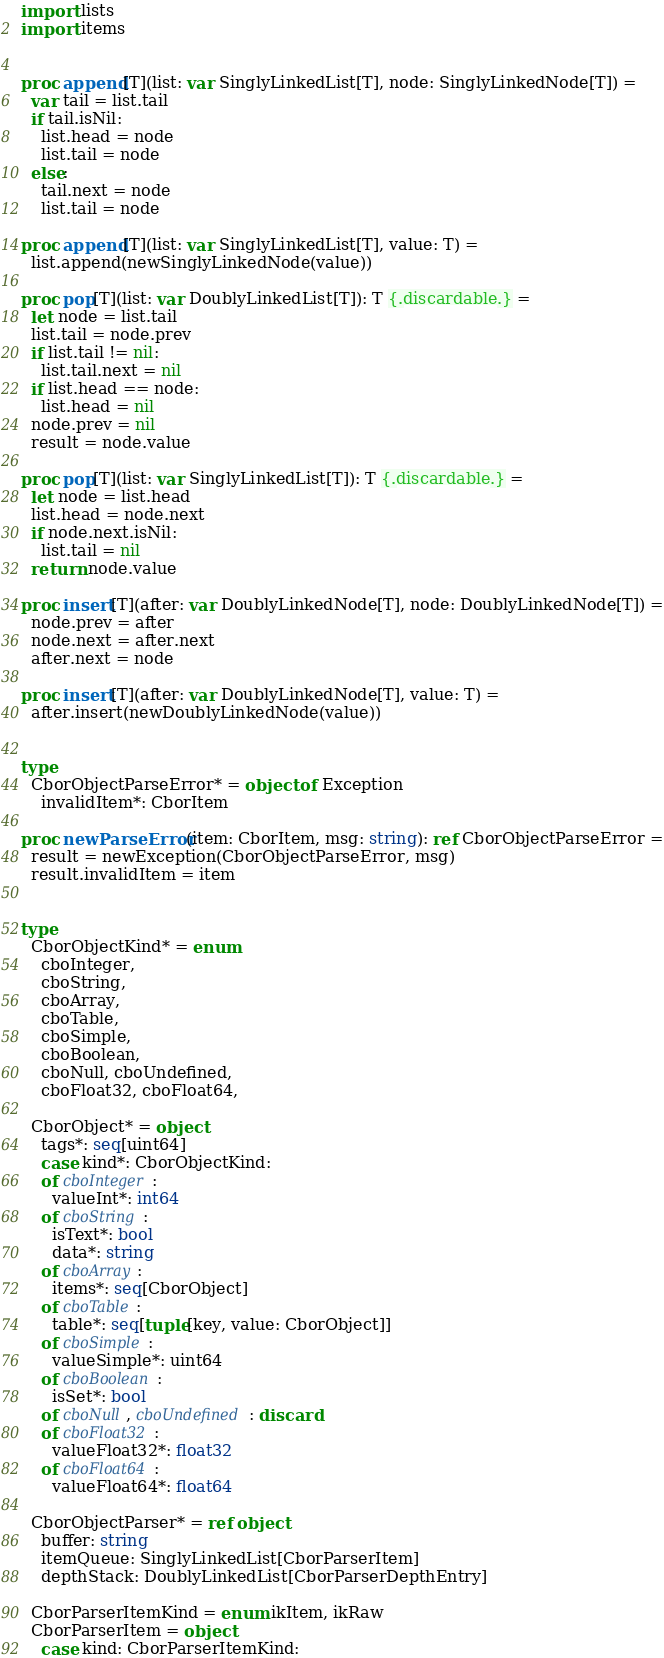<code> <loc_0><loc_0><loc_500><loc_500><_Nim_>import lists
import items


proc append[T](list: var SinglyLinkedList[T], node: SinglyLinkedNode[T]) =
  var tail = list.tail
  if tail.isNil:
    list.head = node
    list.tail = node
  else:
    tail.next = node
    list.tail = node

proc append[T](list: var SinglyLinkedList[T], value: T) =
  list.append(newSinglyLinkedNode(value))

proc pop[T](list: var DoublyLinkedList[T]): T {.discardable.} =
  let node = list.tail
  list.tail = node.prev
  if list.tail != nil:
    list.tail.next = nil
  if list.head == node:
    list.head = nil
  node.prev = nil
  result = node.value

proc pop[T](list: var SinglyLinkedList[T]): T {.discardable.} =
  let node = list.head
  list.head = node.next
  if node.next.isNil:
    list.tail = nil
  return node.value

proc insert[T](after: var DoublyLinkedNode[T], node: DoublyLinkedNode[T]) =
  node.prev = after
  node.next = after.next
  after.next = node

proc insert[T](after: var DoublyLinkedNode[T], value: T) =
  after.insert(newDoublyLinkedNode(value))


type
  CborObjectParseError* = object of Exception
    invalidItem*: CborItem

proc newParseError(item: CborItem, msg: string): ref CborObjectParseError =
  result = newException(CborObjectParseError, msg)
  result.invalidItem = item


type
  CborObjectKind* = enum
    cboInteger,
    cboString,
    cboArray,
    cboTable,
    cboSimple,
    cboBoolean,
    cboNull, cboUndefined,
    cboFloat32, cboFloat64,

  CborObject* = object
    tags*: seq[uint64]
    case kind*: CborObjectKind:
    of cboInteger:
      valueInt*: int64
    of cboString:
      isText*: bool
      data*: string
    of cboArray:
      items*: seq[CborObject]
    of cboTable:
      table*: seq[tuple[key, value: CborObject]]
    of cboSimple:
      valueSimple*: uint64
    of cboBoolean:
      isSet*: bool
    of cboNull, cboUndefined: discard
    of cboFloat32:
      valueFloat32*: float32
    of cboFloat64:
      valueFloat64*: float64

  CborObjectParser* = ref object
    buffer: string
    itemQueue: SinglyLinkedList[CborParserItem]
    depthStack: DoublyLinkedList[CborParserDepthEntry]

  CborParserItemKind = enum ikItem, ikRaw
  CborParserItem = object
    case kind: CborParserItemKind:</code> 